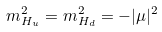<formula> <loc_0><loc_0><loc_500><loc_500>m _ { H _ { u } } ^ { 2 } = m _ { H _ { d } } ^ { 2 } = - | \mu | ^ { 2 }</formula> 